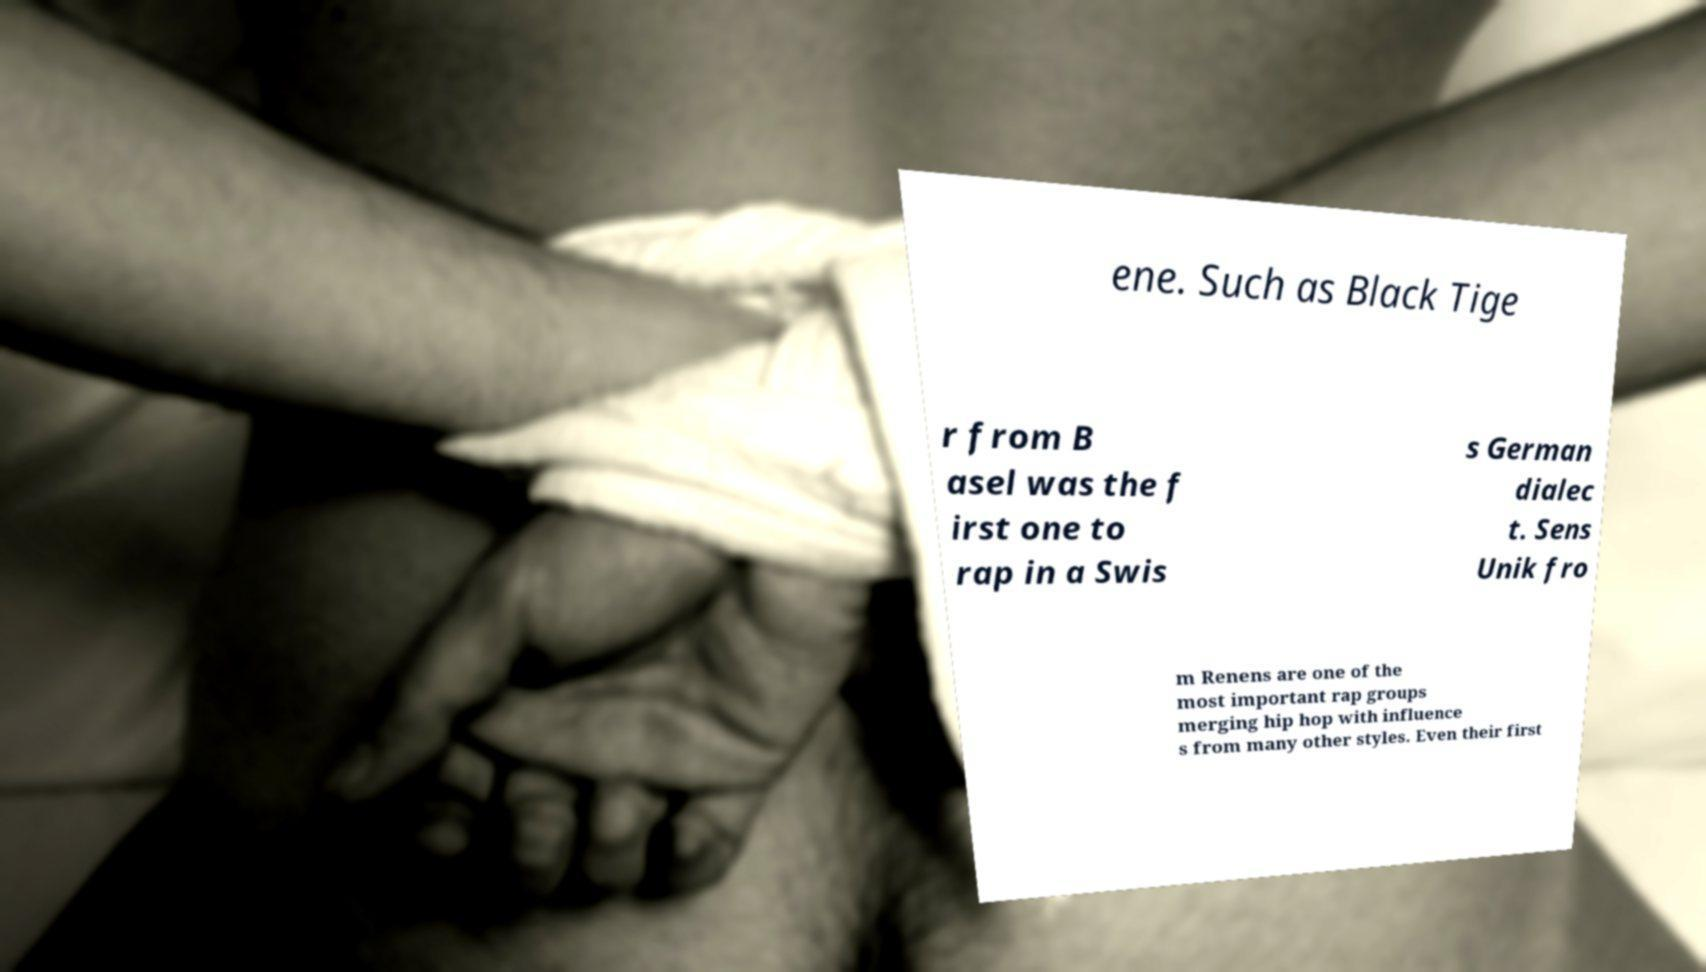What messages or text are displayed in this image? I need them in a readable, typed format. ene. Such as Black Tige r from B asel was the f irst one to rap in a Swis s German dialec t. Sens Unik fro m Renens are one of the most important rap groups merging hip hop with influence s from many other styles. Even their first 